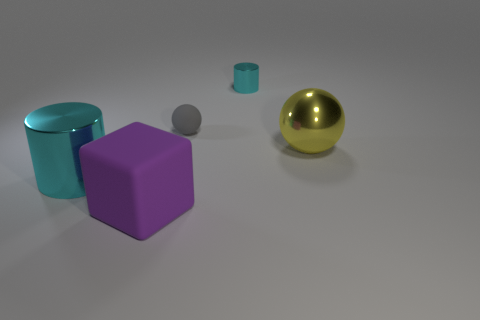Add 2 tiny matte spheres. How many objects exist? 7 Subtract all balls. How many objects are left? 3 Subtract 0 gray blocks. How many objects are left? 5 Subtract all yellow balls. Subtract all big cylinders. How many objects are left? 3 Add 1 shiny spheres. How many shiny spheres are left? 2 Add 5 tiny cyan cylinders. How many tiny cyan cylinders exist? 6 